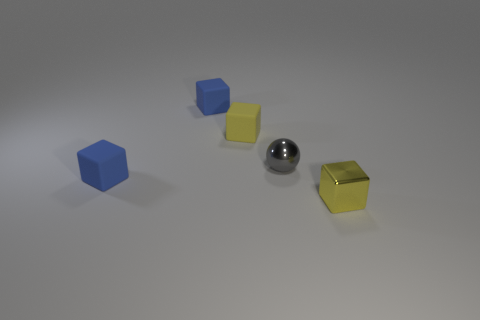Subtract all tiny matte cubes. How many cubes are left? 1 Subtract all brown spheres. How many yellow blocks are left? 2 Subtract 2 cubes. How many cubes are left? 2 Subtract all blue blocks. How many blocks are left? 2 Add 3 big brown metallic objects. How many objects exist? 8 Subtract all small blue cubes. Subtract all rubber objects. How many objects are left? 0 Add 4 yellow shiny objects. How many yellow shiny objects are left? 5 Add 4 small metal blocks. How many small metal blocks exist? 5 Subtract 0 purple cubes. How many objects are left? 5 Subtract all blocks. How many objects are left? 1 